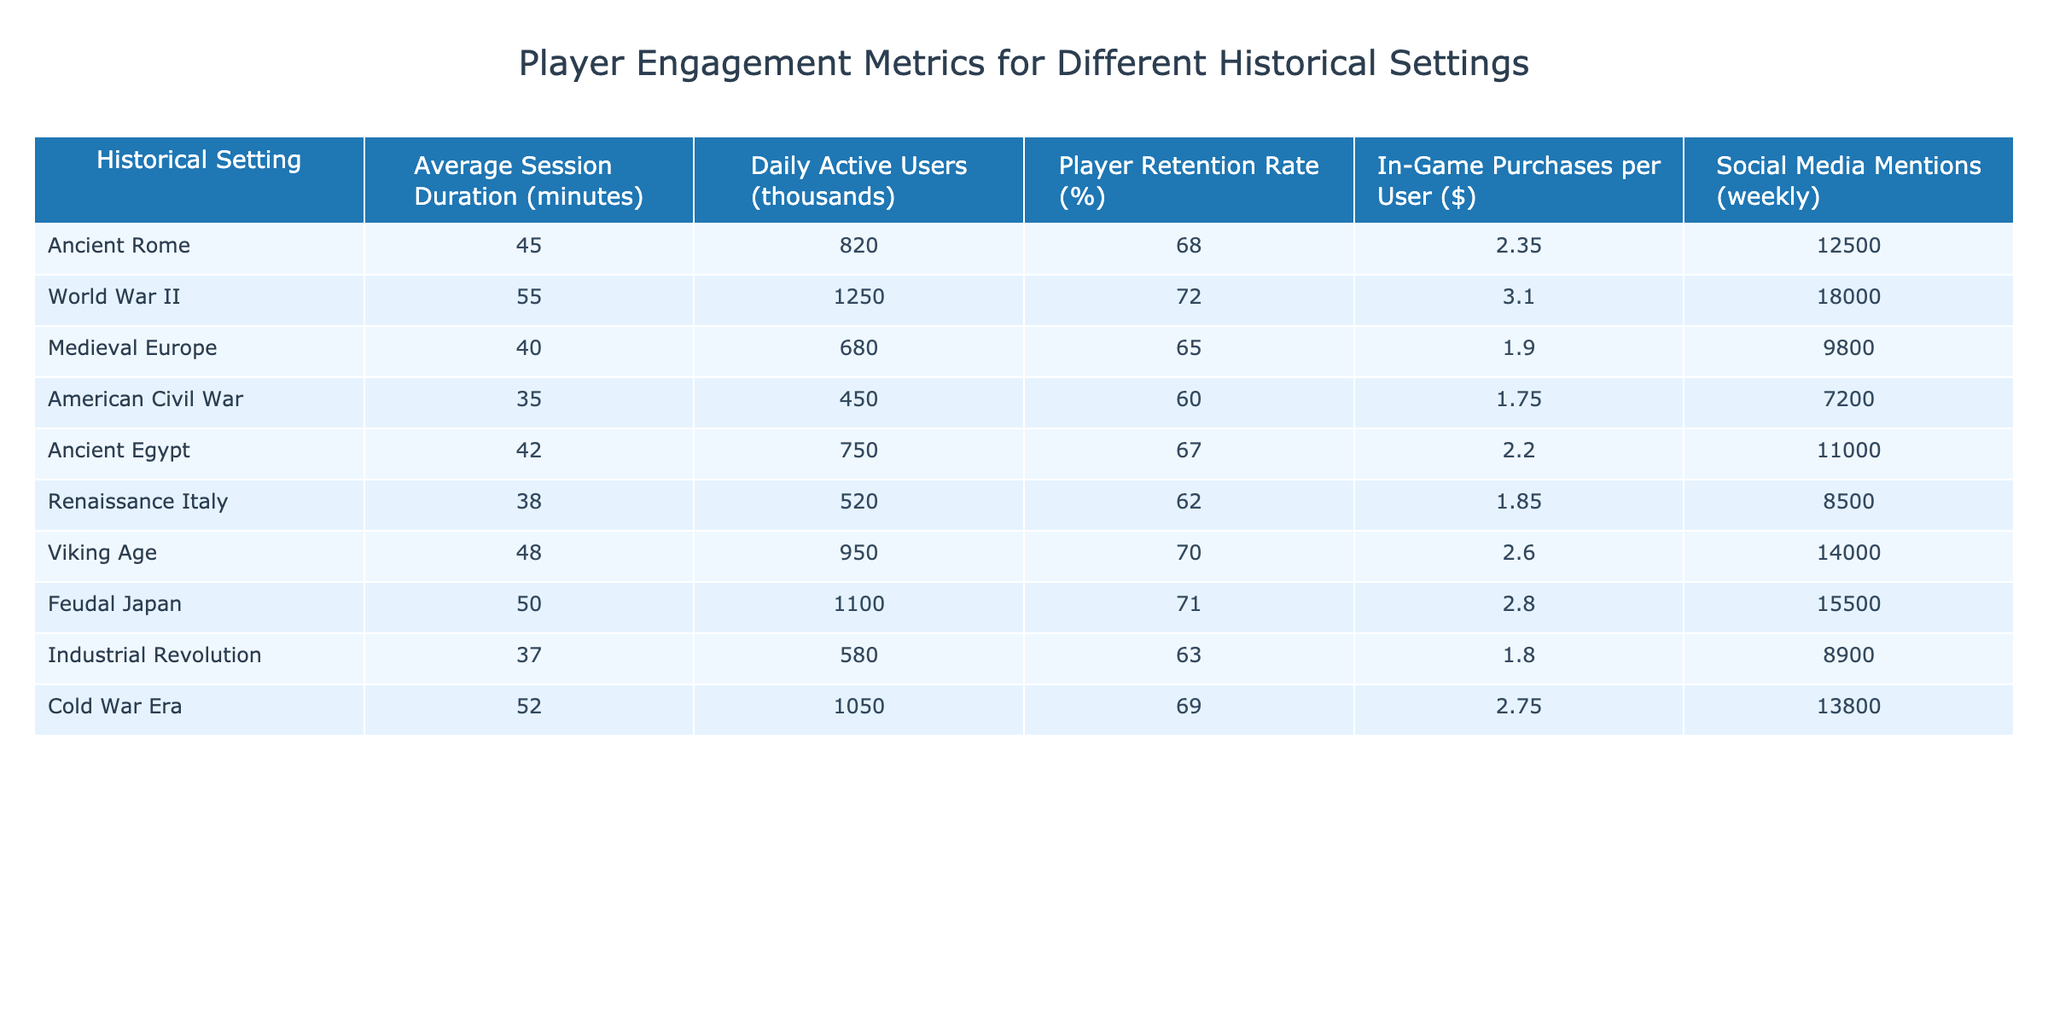What is the average session duration for players in Ancient Rome? The table indicates that the average session duration for players in Ancient Rome is listed as 45 minutes.
Answer: 45 minutes Which historical setting has the highest daily active users? According to the table, World War II has the highest daily active users with 1250 thousand.
Answer: 1250 thousand What is the player retention rate for the Viking Age? The table shows that the player retention rate for the Viking Age is 70%.
Answer: 70% Which historical setting has the lowest in-game purchases per user? By examining the table, the American Civil War has the lowest in-game purchases per user at $1.75.
Answer: $1.75 How many more social media mentions does Feudal Japan have compared to the American Civil War? The table indicates Feudal Japan has 15500 mentions and the American Civil War has 7200 mentions; calculating the difference gives 15500 - 7200 = 8300 more mentions for Feudal Japan.
Answer: 8300 What is the average player retention rate across all historical settings? To find the average player retention rate, add the retention rates (68 + 72 + 65 + 60 + 67 + 62 + 70 + 71 + 63 + 69 = 688), then divide by the number of settings (10): 688 / 10 = 68.8%.
Answer: 68.8% Is the average session duration for World War II higher than for Medieval Europe? The average session duration for World War II is 55 minutes, while for Medieval Europe it is 40 minutes, so yes, it is higher.
Answer: Yes Which historical setting has the highest average in-game purchases per user? Upon reviewing the table, World War II has the highest in-game purchases per user at $3.10.
Answer: $3.10 Which two historical settings have a player retention rate of over 70%? Referring to the table, both World War II (72%) and Feudal Japan (71%) have retention rates over 70%.
Answer: World War II and Feudal Japan What is the relationship between average session duration and player retention rate? World War II has the longest average session duration (55 minutes) and the highest retention rate (72%), while the American Civil War has the shortest session duration (35 minutes) and the lowest retention rate (60%). This suggests a positive correlation where higher session duration may relate to higher retention.
Answer: Positive correlation 